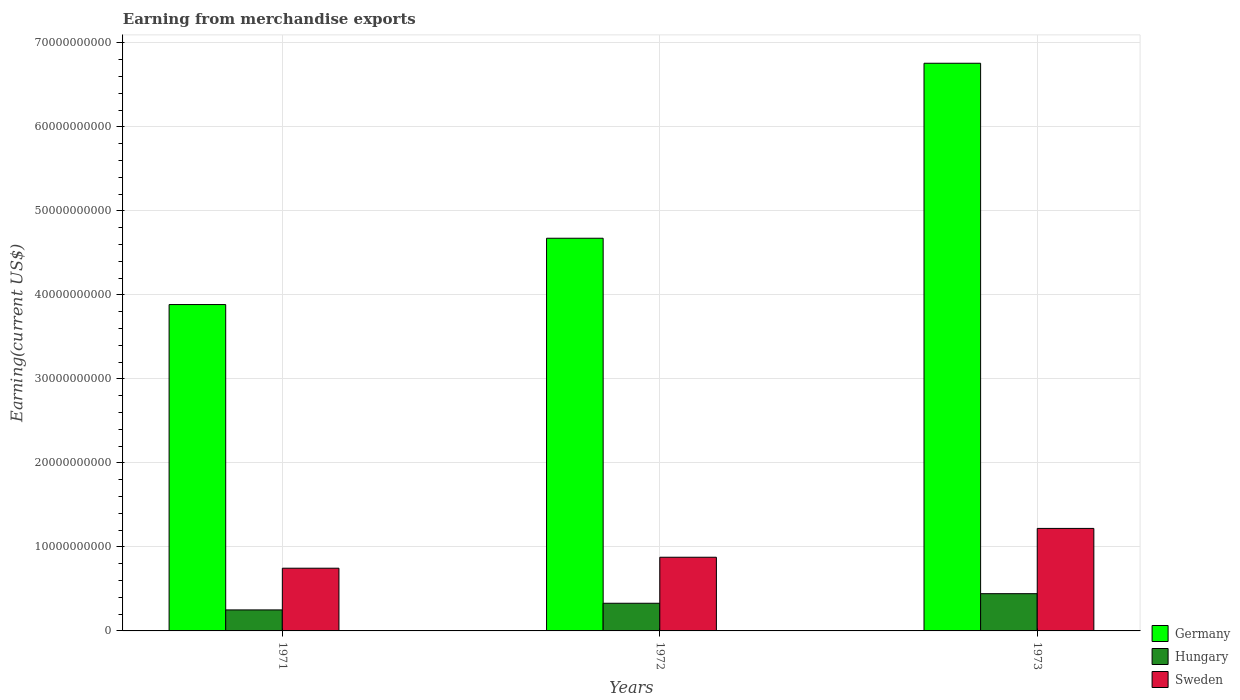How many groups of bars are there?
Provide a succinct answer. 3. Are the number of bars per tick equal to the number of legend labels?
Provide a succinct answer. Yes. Are the number of bars on each tick of the X-axis equal?
Make the answer very short. Yes. How many bars are there on the 2nd tick from the right?
Ensure brevity in your answer.  3. In how many cases, is the number of bars for a given year not equal to the number of legend labels?
Ensure brevity in your answer.  0. What is the amount earned from merchandise exports in Sweden in 1971?
Your response must be concise. 7.46e+09. Across all years, what is the maximum amount earned from merchandise exports in Hungary?
Make the answer very short. 4.43e+09. Across all years, what is the minimum amount earned from merchandise exports in Germany?
Offer a terse response. 3.88e+1. In which year was the amount earned from merchandise exports in Germany maximum?
Your answer should be very brief. 1973. In which year was the amount earned from merchandise exports in Hungary minimum?
Make the answer very short. 1971. What is the total amount earned from merchandise exports in Sweden in the graph?
Your answer should be very brief. 2.84e+1. What is the difference between the amount earned from merchandise exports in Germany in 1971 and that in 1973?
Your response must be concise. -2.87e+1. What is the difference between the amount earned from merchandise exports in Germany in 1972 and the amount earned from merchandise exports in Sweden in 1971?
Offer a terse response. 3.93e+1. What is the average amount earned from merchandise exports in Hungary per year?
Provide a succinct answer. 3.41e+09. In the year 1972, what is the difference between the amount earned from merchandise exports in Germany and amount earned from merchandise exports in Sweden?
Your answer should be very brief. 3.80e+1. In how many years, is the amount earned from merchandise exports in Sweden greater than 28000000000 US$?
Make the answer very short. 0. What is the ratio of the amount earned from merchandise exports in Sweden in 1972 to that in 1973?
Offer a terse response. 0.72. What is the difference between the highest and the second highest amount earned from merchandise exports in Germany?
Provide a short and direct response. 2.08e+1. What is the difference between the highest and the lowest amount earned from merchandise exports in Sweden?
Offer a terse response. 4.74e+09. What does the 2nd bar from the right in 1972 represents?
Keep it short and to the point. Hungary. Are all the bars in the graph horizontal?
Keep it short and to the point. No. Are the values on the major ticks of Y-axis written in scientific E-notation?
Keep it short and to the point. No. How many legend labels are there?
Your response must be concise. 3. How are the legend labels stacked?
Ensure brevity in your answer.  Vertical. What is the title of the graph?
Offer a terse response. Earning from merchandise exports. Does "Belgium" appear as one of the legend labels in the graph?
Provide a short and direct response. No. What is the label or title of the Y-axis?
Keep it short and to the point. Earning(current US$). What is the Earning(current US$) in Germany in 1971?
Your answer should be very brief. 3.88e+1. What is the Earning(current US$) in Hungary in 1971?
Give a very brief answer. 2.50e+09. What is the Earning(current US$) in Sweden in 1971?
Provide a short and direct response. 7.46e+09. What is the Earning(current US$) in Germany in 1972?
Offer a terse response. 4.67e+1. What is the Earning(current US$) of Hungary in 1972?
Your answer should be very brief. 3.29e+09. What is the Earning(current US$) of Sweden in 1972?
Your answer should be very brief. 8.77e+09. What is the Earning(current US$) in Germany in 1973?
Offer a terse response. 6.76e+1. What is the Earning(current US$) of Hungary in 1973?
Your answer should be compact. 4.43e+09. What is the Earning(current US$) of Sweden in 1973?
Make the answer very short. 1.22e+1. Across all years, what is the maximum Earning(current US$) of Germany?
Your answer should be compact. 6.76e+1. Across all years, what is the maximum Earning(current US$) of Hungary?
Offer a terse response. 4.43e+09. Across all years, what is the maximum Earning(current US$) in Sweden?
Your answer should be compact. 1.22e+1. Across all years, what is the minimum Earning(current US$) of Germany?
Provide a succinct answer. 3.88e+1. Across all years, what is the minimum Earning(current US$) in Hungary?
Offer a terse response. 2.50e+09. Across all years, what is the minimum Earning(current US$) in Sweden?
Your answer should be compact. 7.46e+09. What is the total Earning(current US$) in Germany in the graph?
Provide a succinct answer. 1.53e+11. What is the total Earning(current US$) in Hungary in the graph?
Make the answer very short. 1.02e+1. What is the total Earning(current US$) of Sweden in the graph?
Your answer should be compact. 2.84e+1. What is the difference between the Earning(current US$) of Germany in 1971 and that in 1972?
Give a very brief answer. -7.89e+09. What is the difference between the Earning(current US$) of Hungary in 1971 and that in 1972?
Give a very brief answer. -7.92e+08. What is the difference between the Earning(current US$) of Sweden in 1971 and that in 1972?
Your answer should be compact. -1.31e+09. What is the difference between the Earning(current US$) in Germany in 1971 and that in 1973?
Keep it short and to the point. -2.87e+1. What is the difference between the Earning(current US$) of Hungary in 1971 and that in 1973?
Your response must be concise. -1.93e+09. What is the difference between the Earning(current US$) in Sweden in 1971 and that in 1973?
Offer a terse response. -4.74e+09. What is the difference between the Earning(current US$) of Germany in 1972 and that in 1973?
Offer a very short reply. -2.08e+1. What is the difference between the Earning(current US$) in Hungary in 1972 and that in 1973?
Your response must be concise. -1.14e+09. What is the difference between the Earning(current US$) in Sweden in 1972 and that in 1973?
Make the answer very short. -3.43e+09. What is the difference between the Earning(current US$) in Germany in 1971 and the Earning(current US$) in Hungary in 1972?
Offer a terse response. 3.56e+1. What is the difference between the Earning(current US$) of Germany in 1971 and the Earning(current US$) of Sweden in 1972?
Give a very brief answer. 3.01e+1. What is the difference between the Earning(current US$) of Hungary in 1971 and the Earning(current US$) of Sweden in 1972?
Your response must be concise. -6.27e+09. What is the difference between the Earning(current US$) of Germany in 1971 and the Earning(current US$) of Hungary in 1973?
Provide a short and direct response. 3.44e+1. What is the difference between the Earning(current US$) in Germany in 1971 and the Earning(current US$) in Sweden in 1973?
Provide a succinct answer. 2.66e+1. What is the difference between the Earning(current US$) in Hungary in 1971 and the Earning(current US$) in Sweden in 1973?
Keep it short and to the point. -9.70e+09. What is the difference between the Earning(current US$) of Germany in 1972 and the Earning(current US$) of Hungary in 1973?
Offer a terse response. 4.23e+1. What is the difference between the Earning(current US$) of Germany in 1972 and the Earning(current US$) of Sweden in 1973?
Offer a terse response. 3.45e+1. What is the difference between the Earning(current US$) in Hungary in 1972 and the Earning(current US$) in Sweden in 1973?
Provide a short and direct response. -8.91e+09. What is the average Earning(current US$) of Germany per year?
Offer a terse response. 5.10e+1. What is the average Earning(current US$) in Hungary per year?
Keep it short and to the point. 3.41e+09. What is the average Earning(current US$) in Sweden per year?
Ensure brevity in your answer.  9.48e+09. In the year 1971, what is the difference between the Earning(current US$) of Germany and Earning(current US$) of Hungary?
Keep it short and to the point. 3.63e+1. In the year 1971, what is the difference between the Earning(current US$) in Germany and Earning(current US$) in Sweden?
Your response must be concise. 3.14e+1. In the year 1971, what is the difference between the Earning(current US$) of Hungary and Earning(current US$) of Sweden?
Provide a short and direct response. -4.96e+09. In the year 1972, what is the difference between the Earning(current US$) of Germany and Earning(current US$) of Hungary?
Ensure brevity in your answer.  4.34e+1. In the year 1972, what is the difference between the Earning(current US$) in Germany and Earning(current US$) in Sweden?
Ensure brevity in your answer.  3.80e+1. In the year 1972, what is the difference between the Earning(current US$) of Hungary and Earning(current US$) of Sweden?
Provide a short and direct response. -5.48e+09. In the year 1973, what is the difference between the Earning(current US$) in Germany and Earning(current US$) in Hungary?
Your answer should be compact. 6.31e+1. In the year 1973, what is the difference between the Earning(current US$) in Germany and Earning(current US$) in Sweden?
Ensure brevity in your answer.  5.54e+1. In the year 1973, what is the difference between the Earning(current US$) of Hungary and Earning(current US$) of Sweden?
Ensure brevity in your answer.  -7.77e+09. What is the ratio of the Earning(current US$) of Germany in 1971 to that in 1972?
Offer a terse response. 0.83. What is the ratio of the Earning(current US$) of Hungary in 1971 to that in 1972?
Provide a succinct answer. 0.76. What is the ratio of the Earning(current US$) in Sweden in 1971 to that in 1972?
Provide a succinct answer. 0.85. What is the ratio of the Earning(current US$) in Germany in 1971 to that in 1973?
Make the answer very short. 0.57. What is the ratio of the Earning(current US$) in Hungary in 1971 to that in 1973?
Provide a succinct answer. 0.56. What is the ratio of the Earning(current US$) of Sweden in 1971 to that in 1973?
Ensure brevity in your answer.  0.61. What is the ratio of the Earning(current US$) in Germany in 1972 to that in 1973?
Offer a very short reply. 0.69. What is the ratio of the Earning(current US$) in Hungary in 1972 to that in 1973?
Provide a short and direct response. 0.74. What is the ratio of the Earning(current US$) in Sweden in 1972 to that in 1973?
Your response must be concise. 0.72. What is the difference between the highest and the second highest Earning(current US$) of Germany?
Keep it short and to the point. 2.08e+1. What is the difference between the highest and the second highest Earning(current US$) of Hungary?
Make the answer very short. 1.14e+09. What is the difference between the highest and the second highest Earning(current US$) of Sweden?
Make the answer very short. 3.43e+09. What is the difference between the highest and the lowest Earning(current US$) in Germany?
Make the answer very short. 2.87e+1. What is the difference between the highest and the lowest Earning(current US$) in Hungary?
Your answer should be compact. 1.93e+09. What is the difference between the highest and the lowest Earning(current US$) of Sweden?
Ensure brevity in your answer.  4.74e+09. 